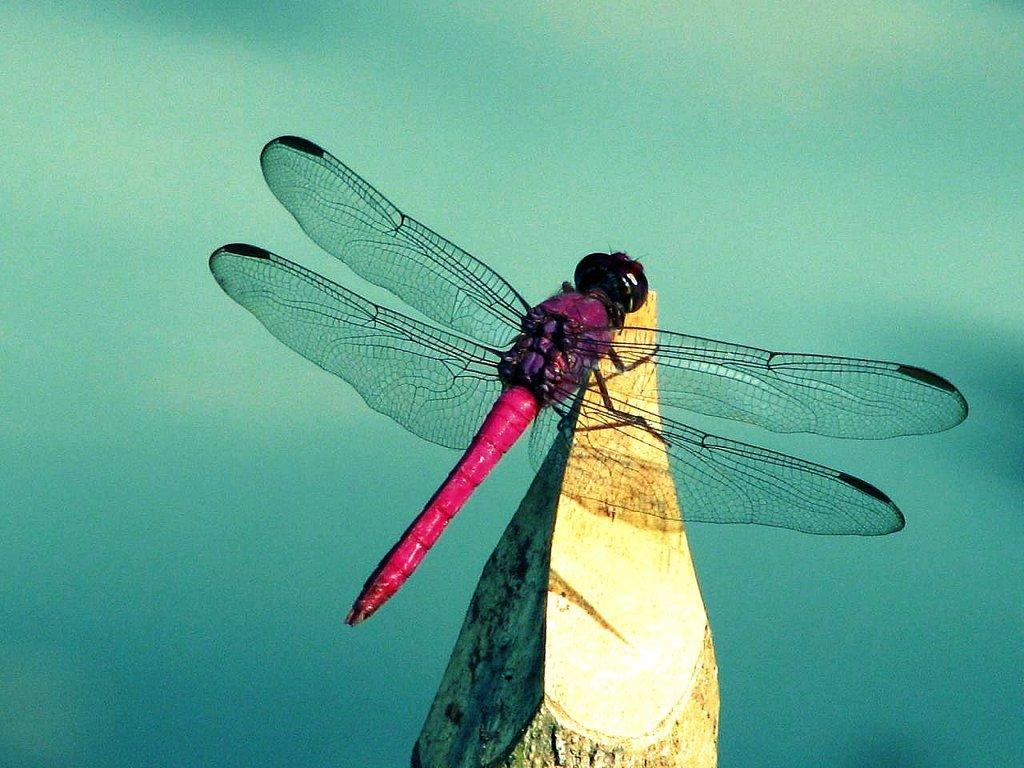In one or two sentences, can you explain what this image depicts? In this image I can see an insect which is black, purple and red in color on the wooden log. I can see the blurry background. 